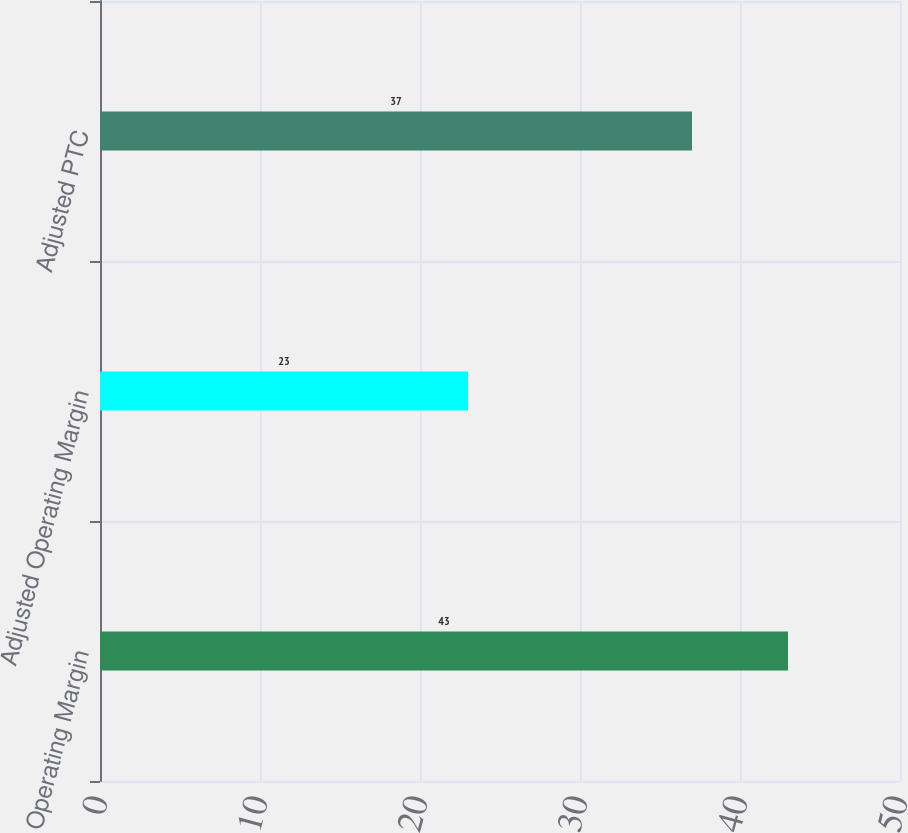Convert chart. <chart><loc_0><loc_0><loc_500><loc_500><bar_chart><fcel>Operating Margin<fcel>Adjusted Operating Margin<fcel>Adjusted PTC<nl><fcel>43<fcel>23<fcel>37<nl></chart> 